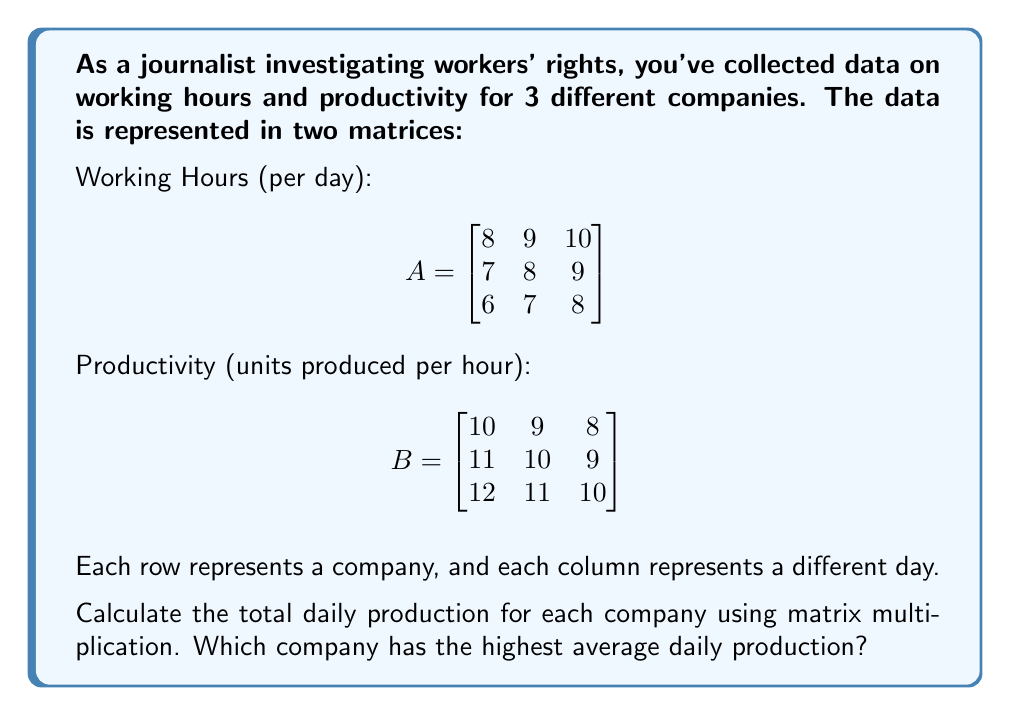Can you answer this question? To solve this problem, we need to follow these steps:

1) Multiply matrices A and B to get the total daily production for each company:

   $$C = A \times B$$

2) The resulting matrix C will show the total units produced per day for each company.

3) Let's perform the matrix multiplication:

   $$C = \begin{bmatrix}
   8(10) + 9(11) + 10(12) & 8(9) + 9(10) + 10(11) & 8(8) + 9(9) + 10(10) \\
   7(10) + 8(11) + 9(12) & 7(9) + 8(10) + 9(11) & 7(8) + 8(9) + 9(10) \\
   6(10) + 7(11) + 8(12) & 6(9) + 7(10) + 8(11) & 6(8) + 7(9) + 8(10)
   \end{bmatrix}$$

4) Calculating each element:

   $$C = \begin{bmatrix}
   80 + 99 + 120 & 72 + 90 + 110 & 64 + 81 + 100 \\
   70 + 88 + 108 & 63 + 80 + 99 & 56 + 72 + 90 \\
   60 + 77 + 96 & 54 + 70 + 88 & 48 + 63 + 80
   \end{bmatrix}$$

5) Simplifying:

   $$C = \begin{bmatrix}
   299 & 272 & 245 \\
   266 & 242 & 218 \\
   233 & 212 & 191
   \end{bmatrix}$$

6) To find the average daily production for each company, we sum the rows and divide by 3:

   Company 1: $(299 + 272 + 245) / 3 = 272$
   Company 2: $(266 + 242 + 218) / 3 = 242$
   Company 3: $(233 + 212 + 191) / 3 = 212$

7) Company 1 has the highest average daily production at 272 units.
Answer: Company 1, with an average daily production of 272 units. 